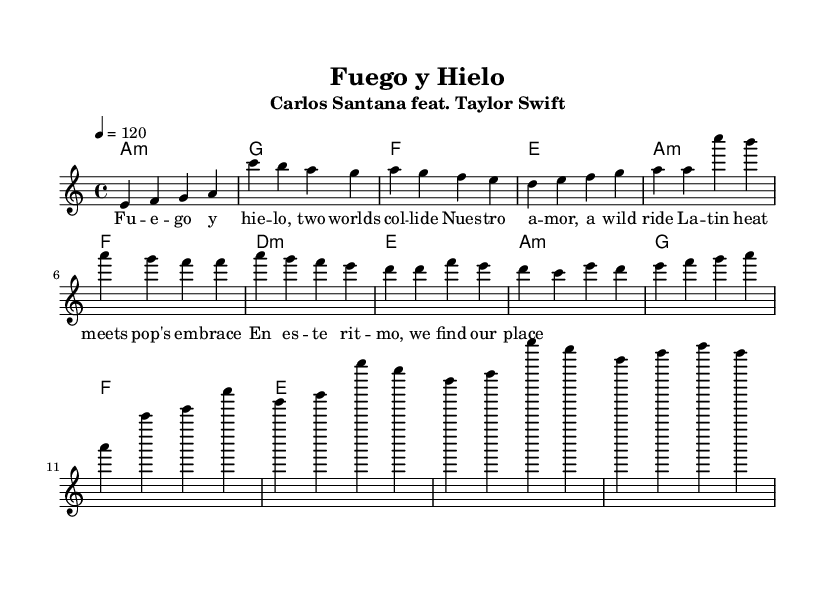What is the key signature of this music? The key signature is A minor, which has no sharps or flats, indicated by the absence of any key signature markings in the music.
Answer: A minor What is the time signature of the piece? The time signature is 4/4, which is shown at the beginning of the music and indicates that there are four beats in each measure.
Answer: 4/4 What is the tempo marking for this piece? The tempo marking is 120 beats per minute, indicated at the beginning of the score with the notation "4 = 120."
Answer: 120 How many measures are in the Chorus section? The Chorus section consists of four measures, visually counted by observing the grouping of the notes and rests in that section.
Answer: 4 What is the primary genre blending represented in this collaboration? The collaboration blends Latin rock elements with mainstream pop influences, as indicated by the artist combination and lyrical themes in the song.
Answer: Latin rock and pop What two main themes are expressed in the lyrics? The lyrics express the themes of love and cultural fusion, which are derived from references to the collision of worlds and the celebration of different cultures.
Answer: Love and cultural fusion How does the harmonic progression in the Chorus differ from the Verse? The Chorus follows a repeating harmonic pattern of A minor, G, F, and E, whereas the Verse has a different sequence, showing more harmonic variation.
Answer: Different harmonic progression 